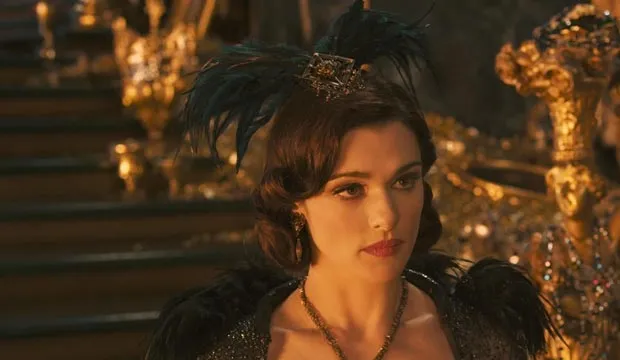Can you explain the significance of the background setting in this image? The golden throne room setting in the background is pivotal as it symbolizes the ultimate seat of power within the Emerald City in 'Oz the Great and Powerful'. It reflects Evanora's high status in the magical realm and her ambition to maintain control over it. The ornate, almost excessive golden decor not only speaks to the wealth of the kingdom but also to the grandiose self-image and the corruptive nature of power that Evanora embodies. 